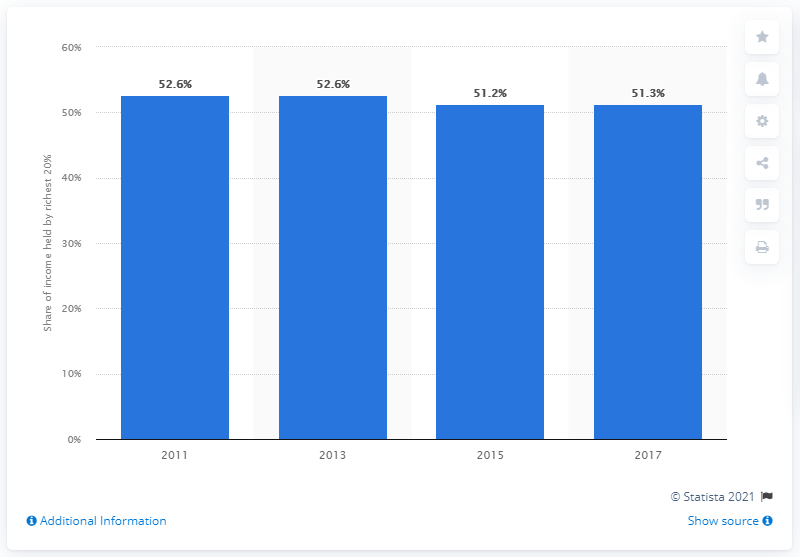Give some essential details in this illustration. In 2017, the richest 20 percent of Chile's population held 51.3 percent of the country's income. Since 2011, the share of the richest 20 percent of Chile's population has been decreasing. 